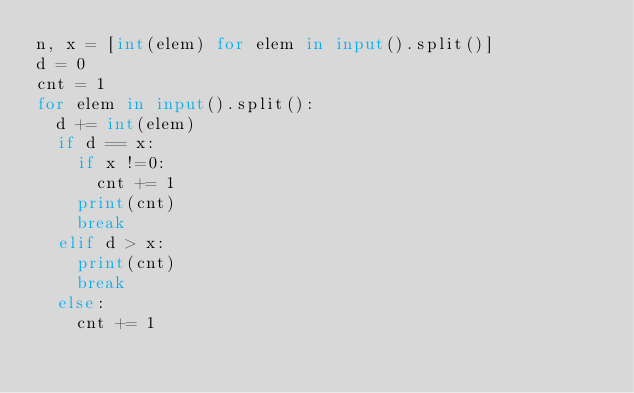<code> <loc_0><loc_0><loc_500><loc_500><_Python_>n, x = [int(elem) for elem in input().split()]
d = 0
cnt = 1
for elem in input().split():
  d += int(elem)
  if d == x:
    if x !=0:
      cnt += 1
    print(cnt)
    break
  elif d > x:
    print(cnt)
    break    
  else:
    cnt += 1</code> 